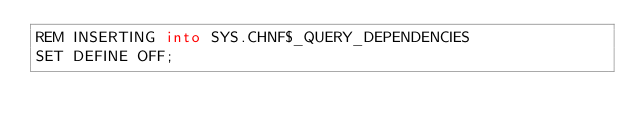Convert code to text. <code><loc_0><loc_0><loc_500><loc_500><_SQL_>REM INSERTING into SYS.CHNF$_QUERY_DEPENDENCIES
SET DEFINE OFF;
</code> 